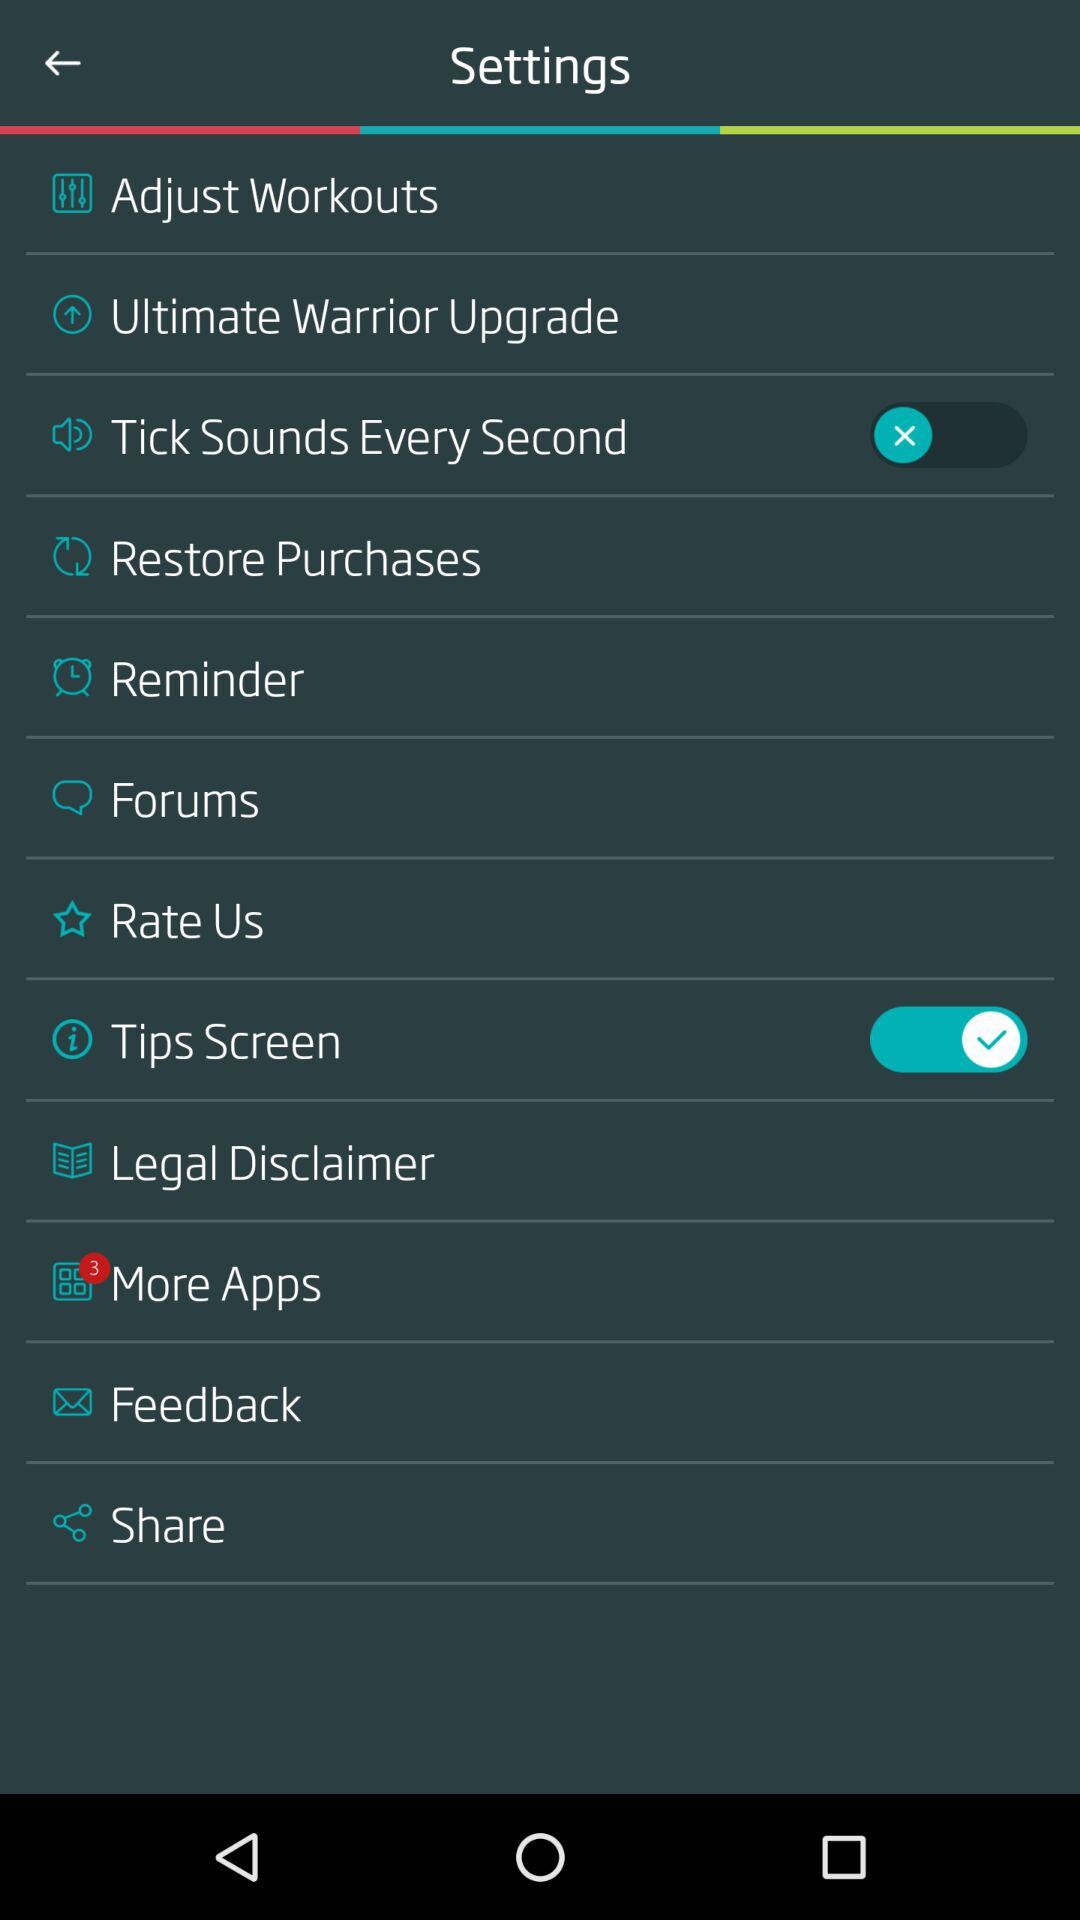What is the unread notification count of "More Apps"? The count is 3. 